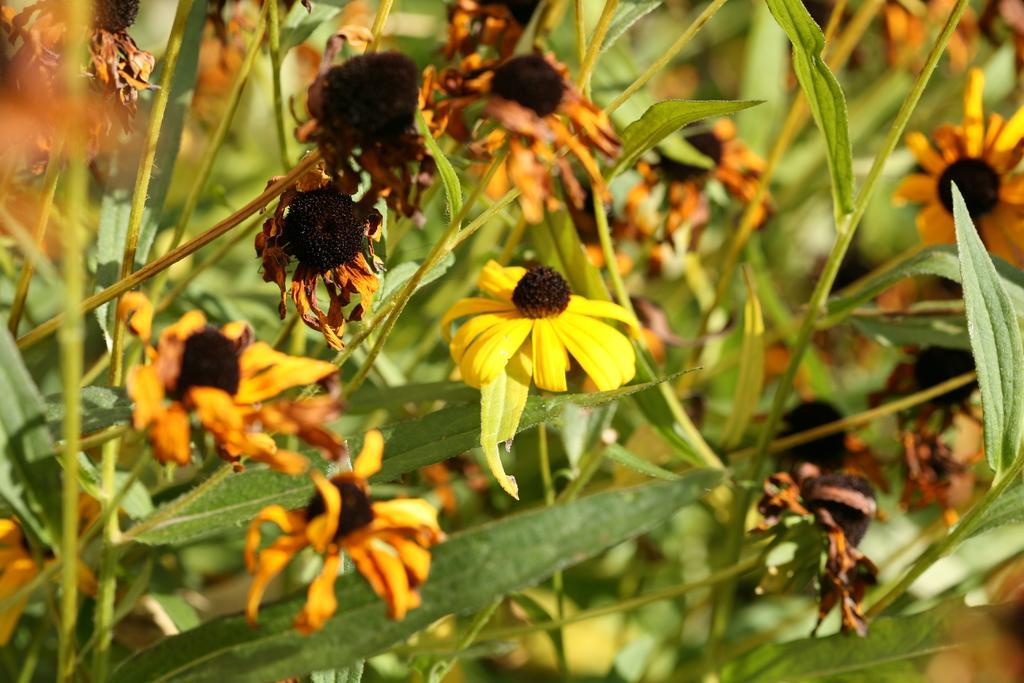Please provide a concise description of this image. In this image I can see yellow and black color flowers. I can see green color leaves. 